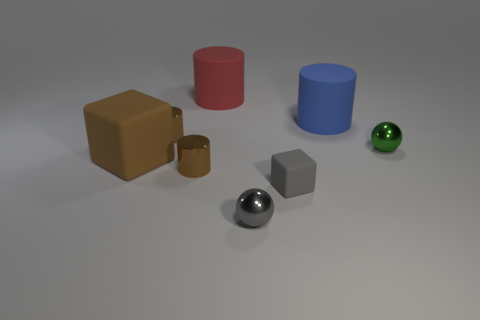Which objects are metallic, and can you describe their shine? There are two metallic objects in the scene which include the silver sphere and the cube. They both have a reflective surface that creates highlights and subtle reflections of the environment, giving them a realistic metallic appearance. 